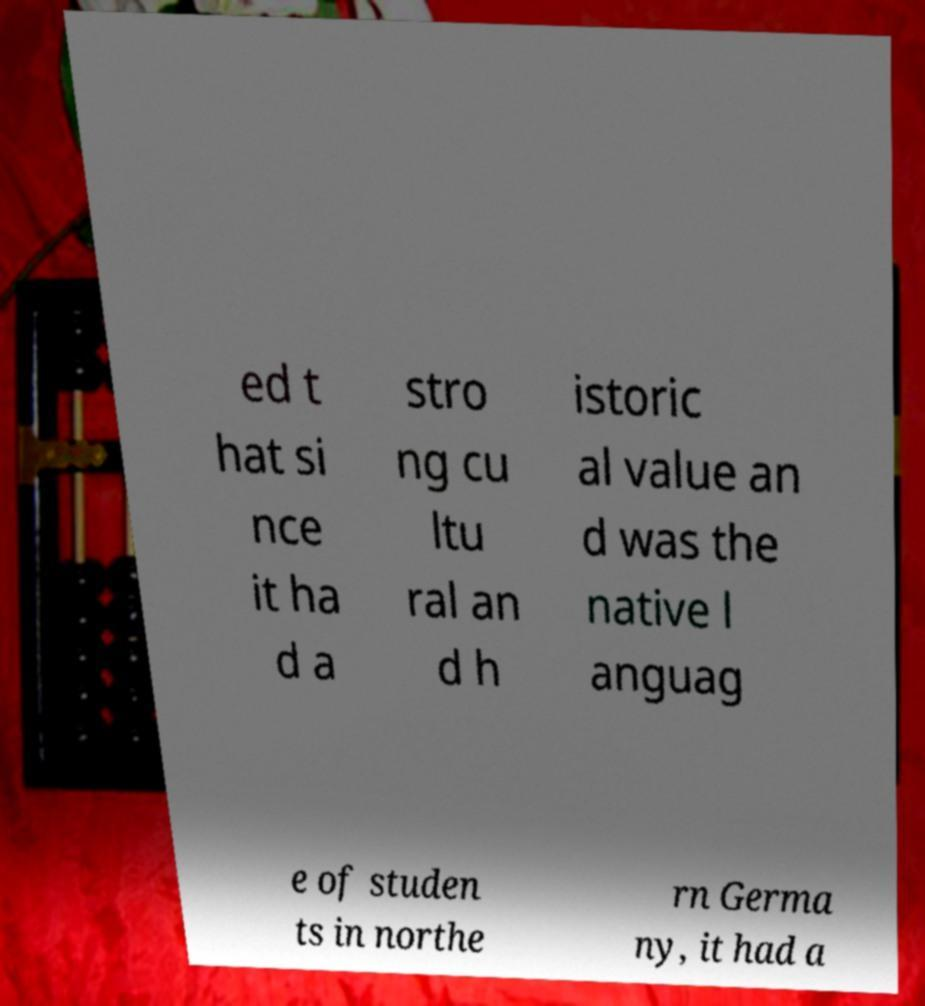Can you accurately transcribe the text from the provided image for me? ed t hat si nce it ha d a stro ng cu ltu ral an d h istoric al value an d was the native l anguag e of studen ts in northe rn Germa ny, it had a 